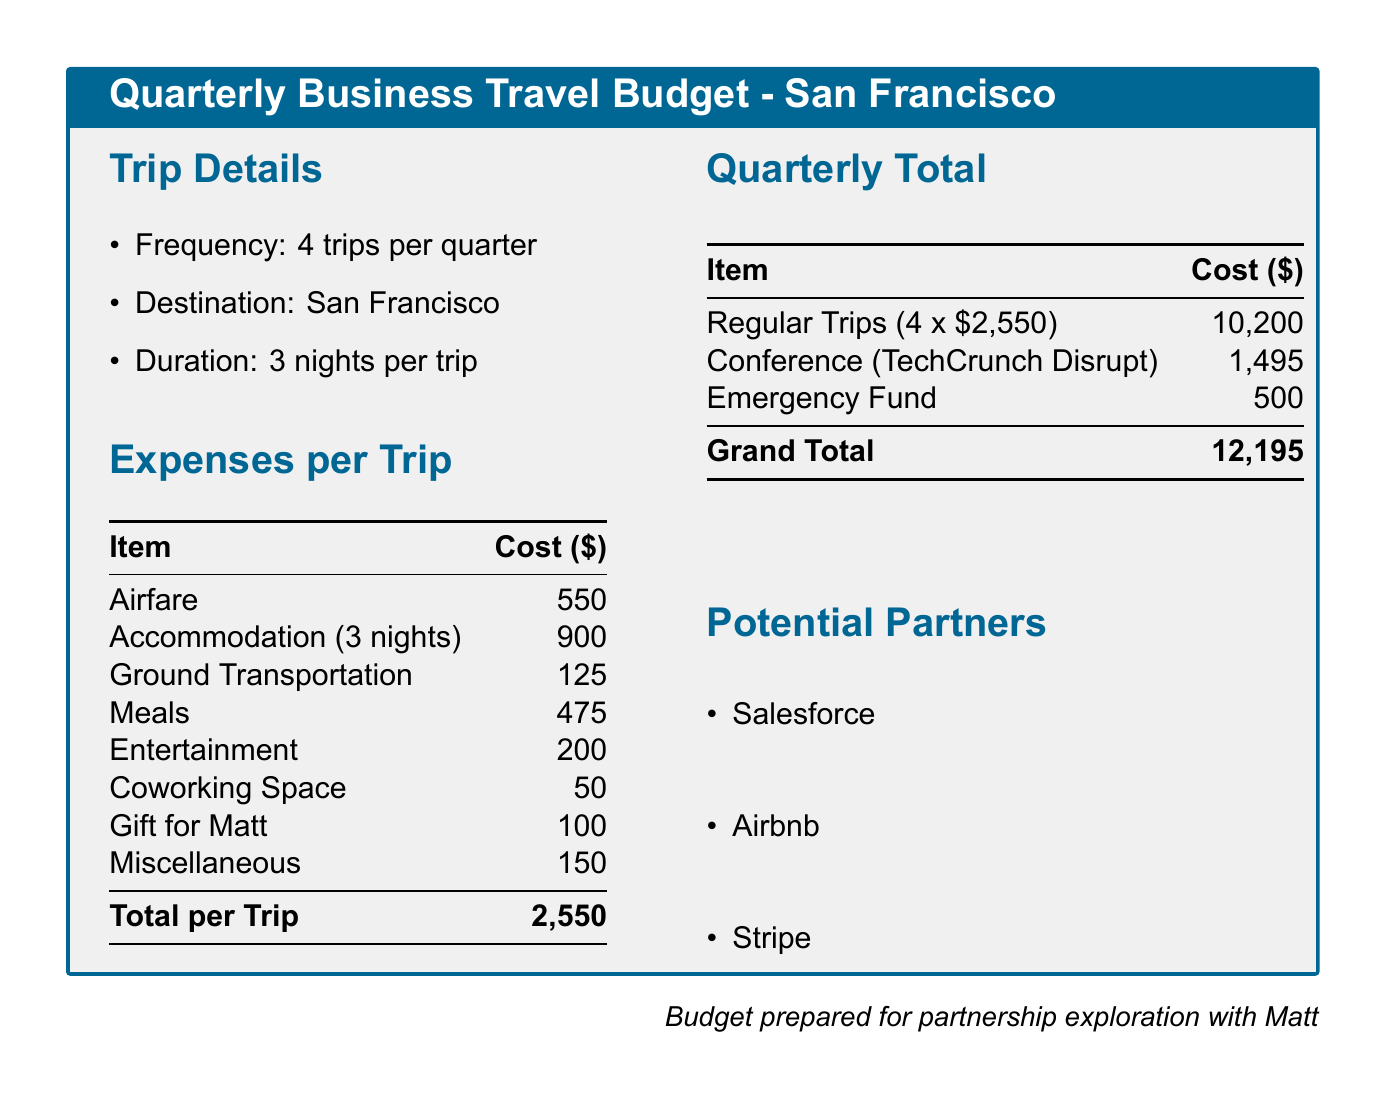What is the destination of the trips? The destination specified for the trips in the budget is San Francisco.
Answer: San Francisco How much is the airfare per trip? The budget lists the airfare cost per trip as $550.
Answer: 550 What is the total cost for one trip? The total cost is calculated by adding all expenses per trip, which totals $2,550.
Answer: 2,550 How many trips are planned each quarter? The document states that there are 4 trips planned per quarter.
Answer: 4 What is the grand total for the quarterly budget? The grand total for the quarterly budget is the sum of regular trips, conference attendance, and emergency fund, totaling $12,195.
Answer: 12,195 What is the estimated cost for meals per trip? The budget lists the cost for meals as $475 per trip.
Answer: 475 Which conference is included in the quarterly total? The conference mentioned in the budget is TechCrunch Disrupt.
Answer: TechCrunch Disrupt What is included in the miscellaneous expenses? The document states that miscellaneous expenses total $150 but does not specify further details within that category.
Answer: 150 Who are the potential partners mentioned? The potential partners listed in the document are Salesforce, Airbnb, and Stripe.
Answer: Salesforce, Airbnb, Stripe 